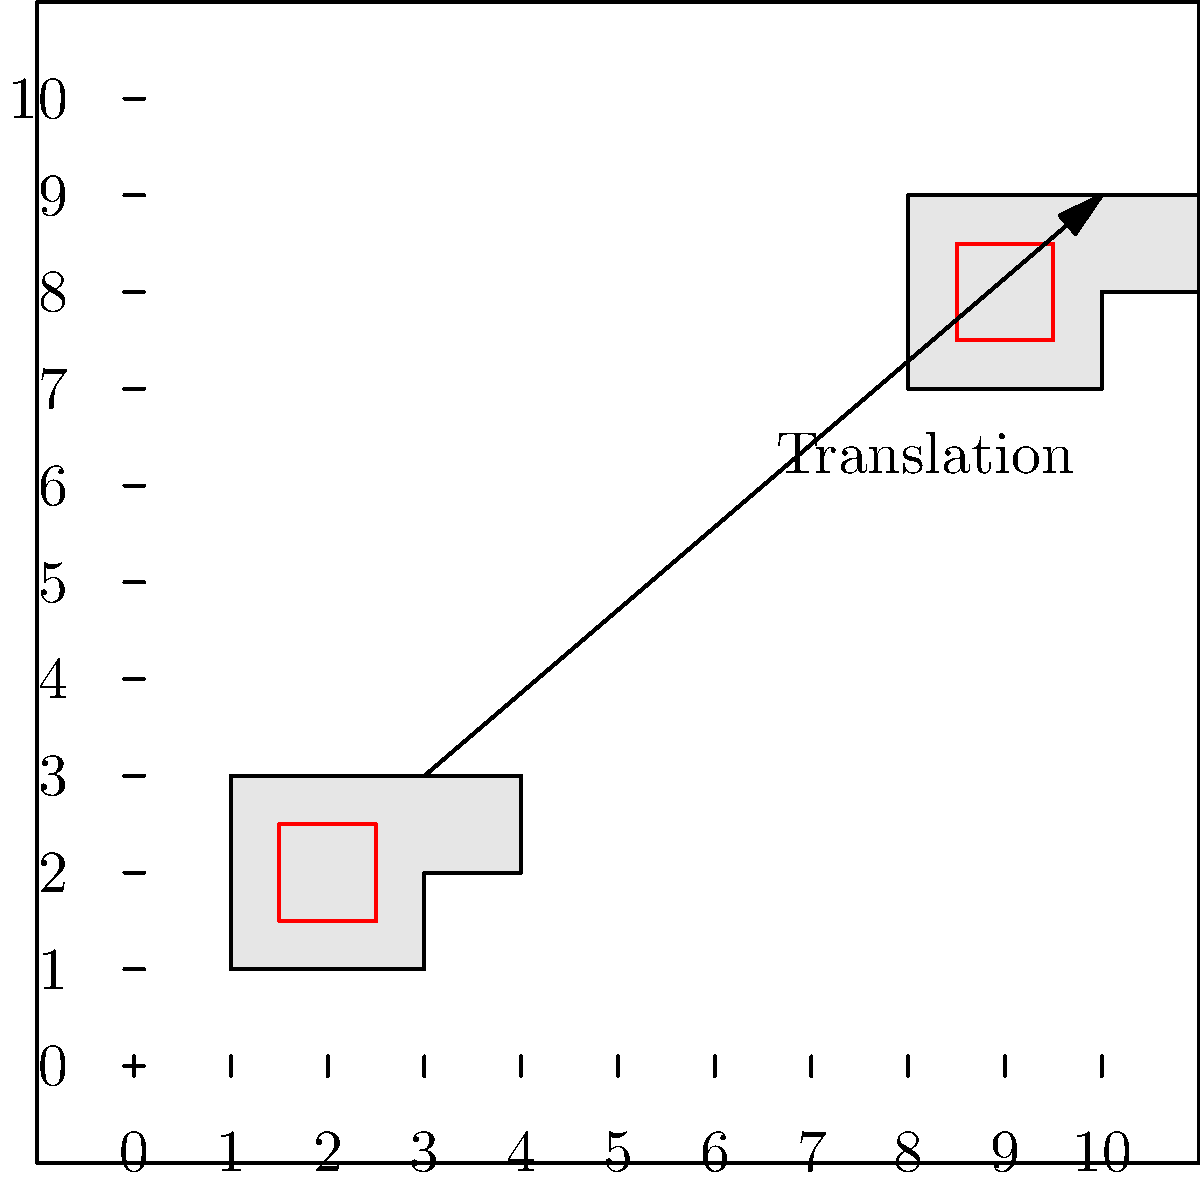An ambulance is represented by a shape on a coordinate plane. It is initially positioned with its bottom-left corner at (1, 1). After responding to an emergency call, the ambulance is translated to a new position. If the bottom-left corner of the ambulance is now at (8, 7), what is the translation vector that describes this movement? To find the translation vector, we need to follow these steps:

1) Identify the initial position: The bottom-left corner of the ambulance starts at (1, 1).

2) Identify the final position: The bottom-left corner of the ambulance ends at (8, 7).

3) Calculate the change in x-coordinate:
   $\Delta x = 8 - 1 = 7$

4) Calculate the change in y-coordinate:
   $\Delta y = 7 - 1 = 6$

5) The translation vector is represented by these changes:
   $\vec{v} = \langle \Delta x, \Delta y \rangle = \langle 7, 6 \rangle$

This vector $\langle 7, 6 \rangle$ represents the movement of the ambulance 7 units right and 6 units up.
Answer: $\langle 7, 6 \rangle$ 